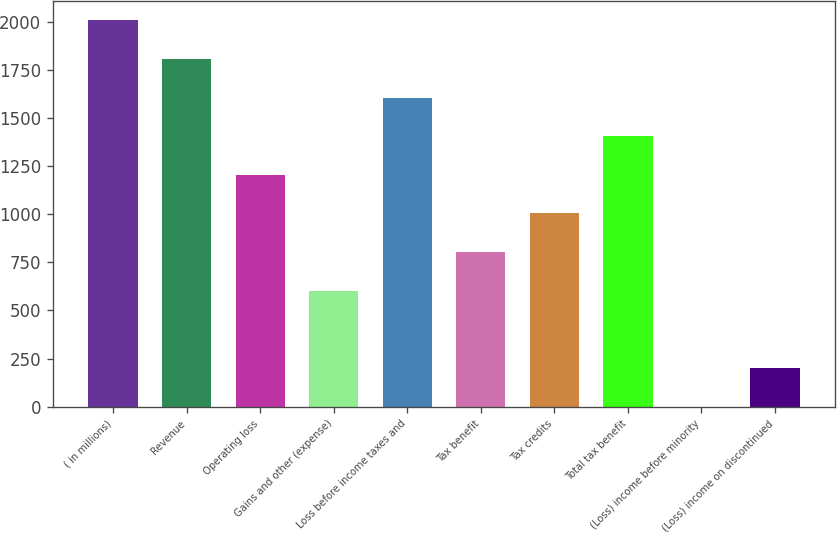Convert chart. <chart><loc_0><loc_0><loc_500><loc_500><bar_chart><fcel>( in millions)<fcel>Revenue<fcel>Operating loss<fcel>Gains and other (expense)<fcel>Loss before income taxes and<fcel>Tax benefit<fcel>Tax credits<fcel>Total tax benefit<fcel>(Loss) income before minority<fcel>(Loss) income on discontinued<nl><fcel>2007<fcel>1806.4<fcel>1204.6<fcel>602.8<fcel>1605.8<fcel>803.4<fcel>1004<fcel>1405.2<fcel>1<fcel>201.6<nl></chart> 